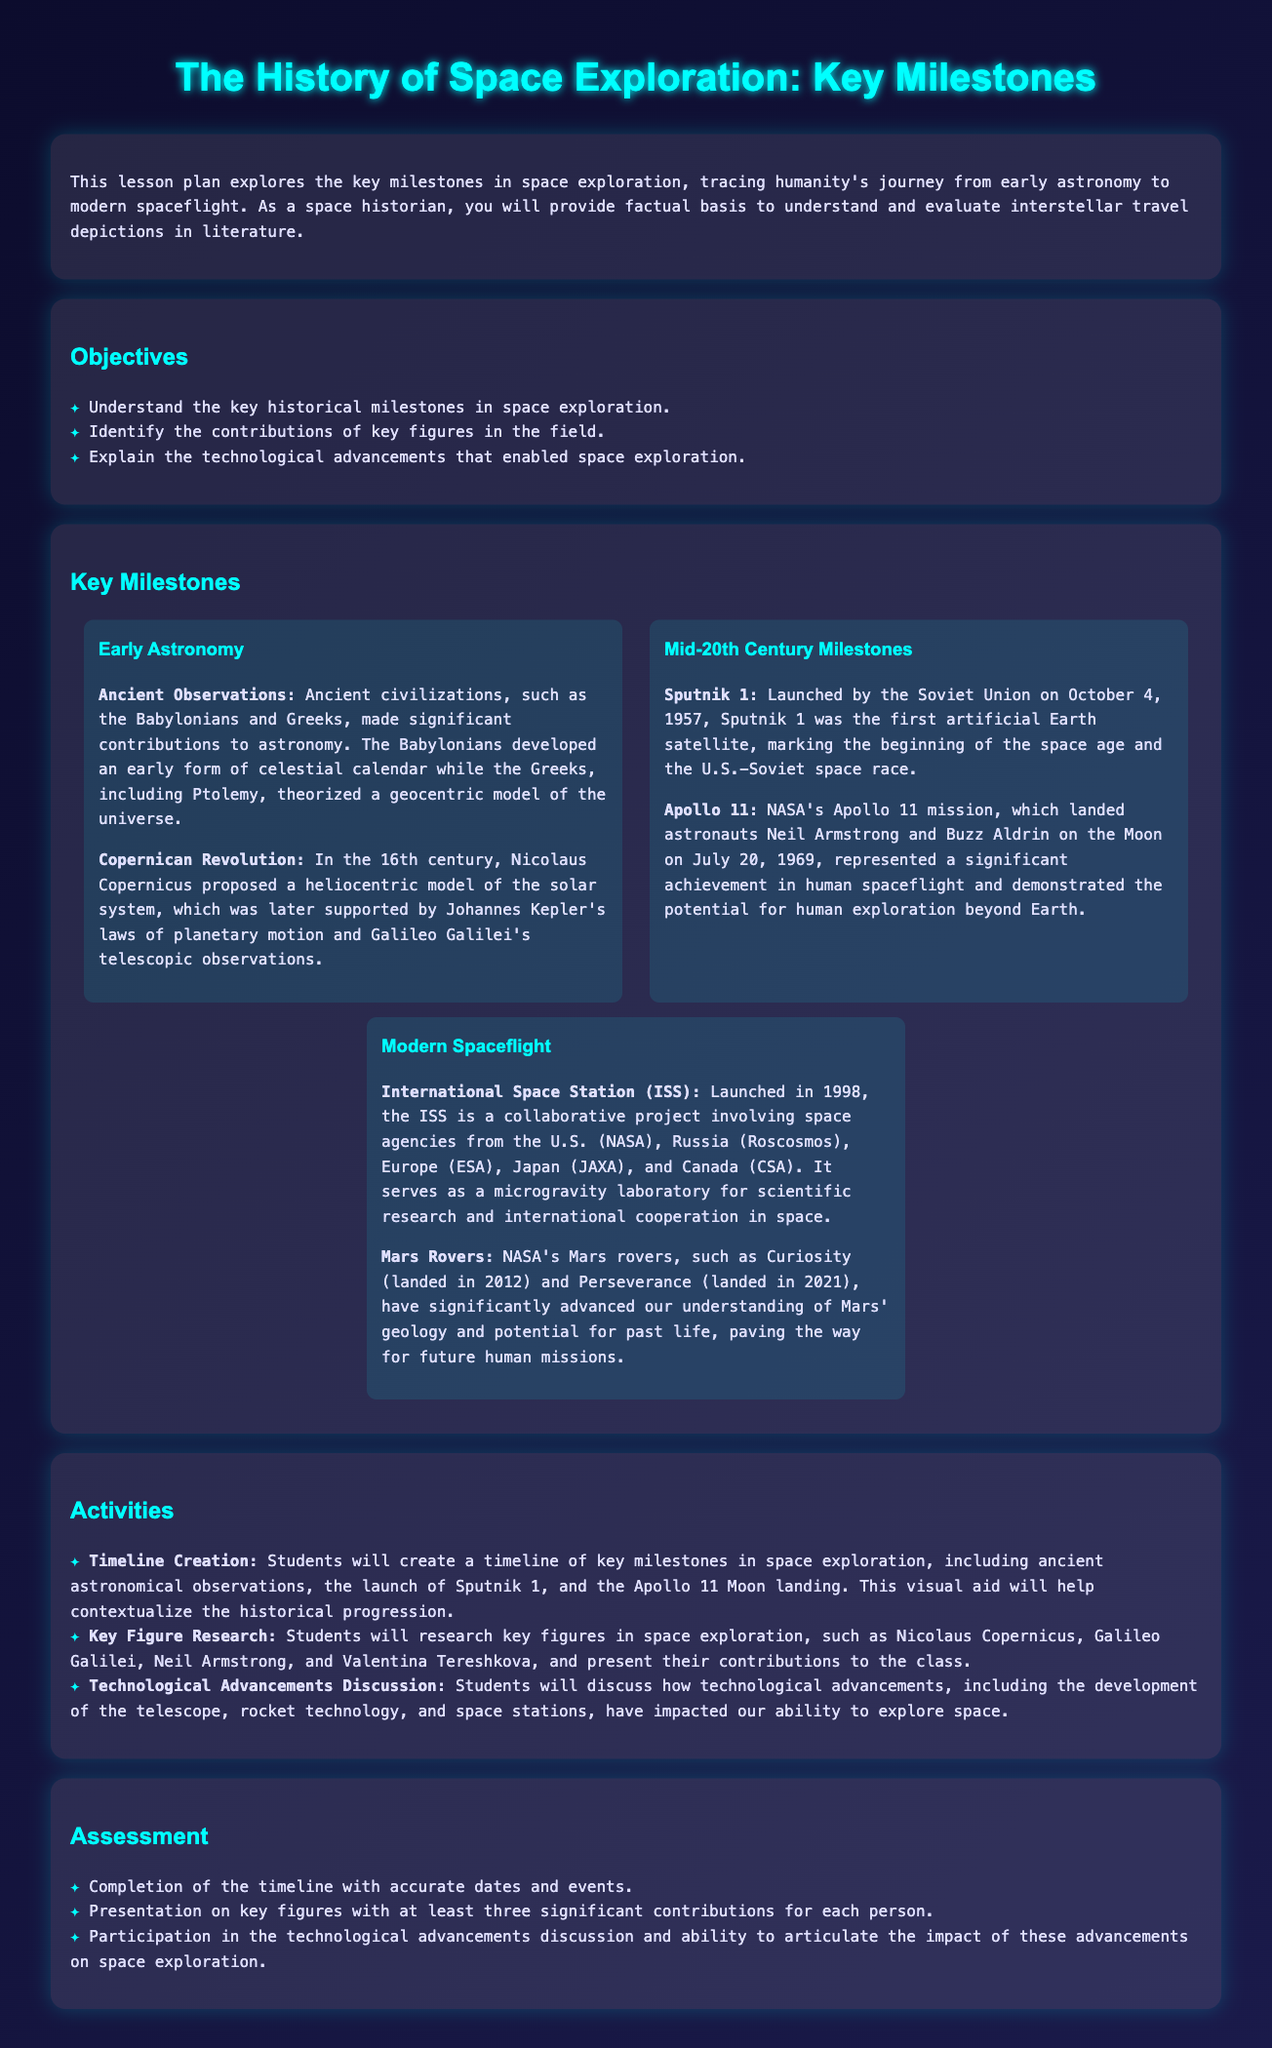What was launched on October 4, 1957? Sputnik 1 is mentioned as the first artificial Earth satellite launched by the Soviet Union on this date.
Answer: Sputnik 1 Who landed on the Moon during Apollo 11? The lesson mentions that astronauts Neil Armstrong and Buzz Aldrin were the ones who landed on the Moon during this mission.
Answer: Neil Armstrong and Buzz Aldrin What year was the International Space Station launched? The document states that the ISS was launched in 1998, making it a key milestone in modern spaceflight.
Answer: 1998 Which rover landed on Mars in 2021? According to the document, Perseverance is the NASA rover that landed on Mars in 2021, contributing to our understanding of the planet.
Answer: Perseverance What major revolution did Nicolaus Copernicus propose in the 16th century? The document highlights that Copernicus proposed a heliocentric model of the solar system, which challenged the previous geocentric views.
Answer: Heliocentric model How many significant contributions are required for the presentation on key figures? The assessment section specifies that at least three significant contributions for each figure are needed for the presentations.
Answer: Three What is the main focus of the lesson plan? The lesson plan discusses tracing humanity's journey from early astronomy to modern spaceflight with a focus on key milestones.
Answer: Key milestones in space exploration Which two agencies collaborated to launch the ISS? The materials indicate that the ISS is a collaborative project involving NASA (U.S.) and Roscosmos (Russia), among others.
Answer: NASA and Roscosmos 